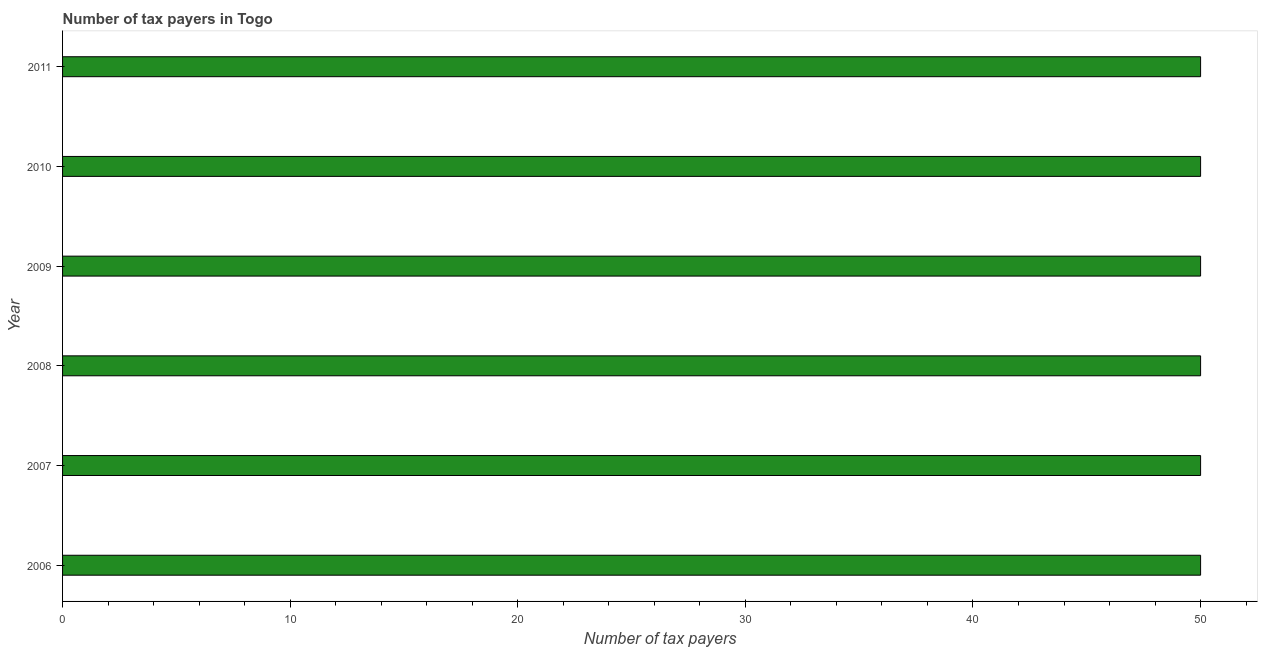What is the title of the graph?
Provide a succinct answer. Number of tax payers in Togo. What is the label or title of the X-axis?
Provide a short and direct response. Number of tax payers. What is the label or title of the Y-axis?
Give a very brief answer. Year. In which year was the number of tax payers maximum?
Give a very brief answer. 2006. What is the sum of the number of tax payers?
Give a very brief answer. 300. What is the average number of tax payers per year?
Make the answer very short. 50. What is the median number of tax payers?
Offer a very short reply. 50. In how many years, is the number of tax payers greater than 12 ?
Provide a short and direct response. 6. Do a majority of the years between 2011 and 2010 (inclusive) have number of tax payers greater than 24 ?
Your answer should be very brief. No. What is the ratio of the number of tax payers in 2007 to that in 2010?
Your answer should be compact. 1. Is the difference between the number of tax payers in 2008 and 2009 greater than the difference between any two years?
Ensure brevity in your answer.  Yes. What is the difference between the highest and the second highest number of tax payers?
Provide a short and direct response. 0. What is the difference between the highest and the lowest number of tax payers?
Ensure brevity in your answer.  0. In how many years, is the number of tax payers greater than the average number of tax payers taken over all years?
Your answer should be very brief. 0. How many bars are there?
Make the answer very short. 6. What is the Number of tax payers in 2008?
Offer a very short reply. 50. What is the Number of tax payers of 2009?
Offer a terse response. 50. What is the difference between the Number of tax payers in 2006 and 2007?
Provide a short and direct response. 0. What is the difference between the Number of tax payers in 2007 and 2011?
Provide a succinct answer. 0. What is the difference between the Number of tax payers in 2008 and 2010?
Make the answer very short. 0. What is the difference between the Number of tax payers in 2008 and 2011?
Your answer should be compact. 0. What is the difference between the Number of tax payers in 2009 and 2010?
Provide a succinct answer. 0. What is the ratio of the Number of tax payers in 2006 to that in 2009?
Give a very brief answer. 1. What is the ratio of the Number of tax payers in 2006 to that in 2010?
Offer a terse response. 1. What is the ratio of the Number of tax payers in 2006 to that in 2011?
Give a very brief answer. 1. What is the ratio of the Number of tax payers in 2007 to that in 2009?
Your response must be concise. 1. What is the ratio of the Number of tax payers in 2007 to that in 2011?
Your answer should be compact. 1. What is the ratio of the Number of tax payers in 2008 to that in 2010?
Offer a very short reply. 1. What is the ratio of the Number of tax payers in 2008 to that in 2011?
Keep it short and to the point. 1. What is the ratio of the Number of tax payers in 2009 to that in 2010?
Offer a terse response. 1. What is the ratio of the Number of tax payers in 2009 to that in 2011?
Your answer should be compact. 1. 